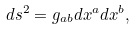<formula> <loc_0><loc_0><loc_500><loc_500>d s ^ { 2 } = g _ { a b } d x ^ { a } d x ^ { b } ,</formula> 